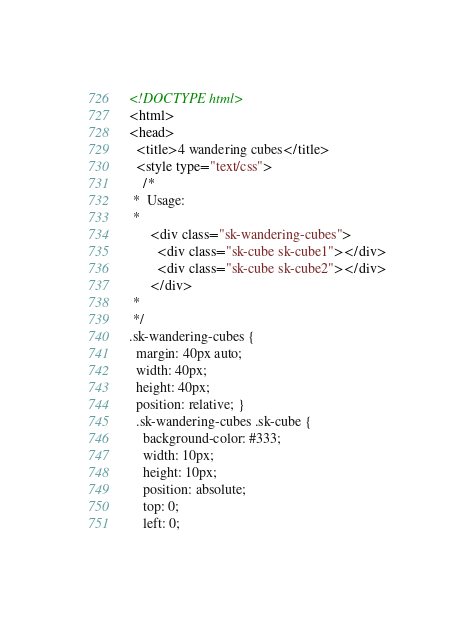Convert code to text. <code><loc_0><loc_0><loc_500><loc_500><_HTML_><!DOCTYPE html>
<html>
<head>
  <title>4 wandering cubes</title>
  <style type="text/css">
    /*
 *  Usage:
 *
      <div class="sk-wandering-cubes">
        <div class="sk-cube sk-cube1"></div>
        <div class="sk-cube sk-cube2"></div>
      </div>
 *
 */
.sk-wandering-cubes {
  margin: 40px auto;
  width: 40px;
  height: 40px;
  position: relative; }
  .sk-wandering-cubes .sk-cube {
    background-color: #333;
    width: 10px;
    height: 10px;
    position: absolute;
    top: 0;
    left: 0;</code> 